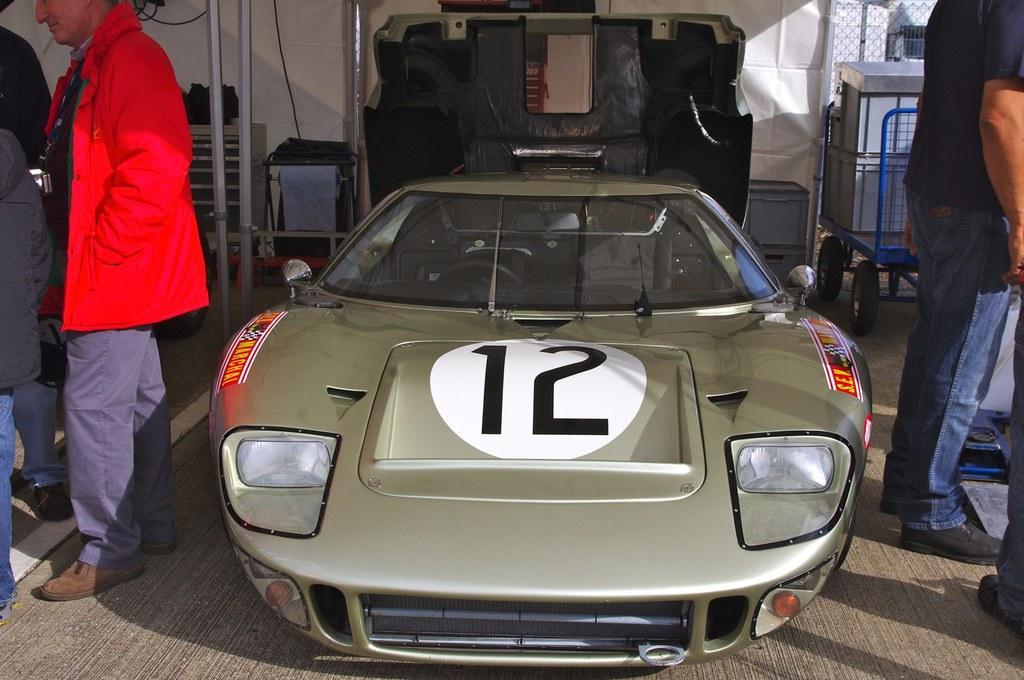Please provide a concise description of this image. In this image we can see green color. Both sides of the image men are standing. Background of the image white color sheet and some metal things are present. 